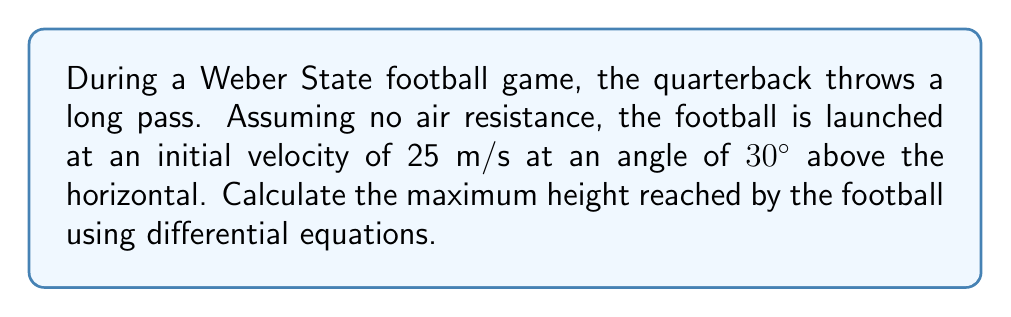Solve this math problem. Let's approach this problem using differential equations:

1. Define variables:
   $x$: horizontal position
   $y$: vertical position
   $t$: time
   $g$: acceleration due to gravity (9.8 m/s²)
   $v_0$: initial velocity (25 m/s)
   $\theta$: launch angle (30°)

2. Set up differential equations:
   $$\frac{d^2x}{dt^2} = 0$$
   $$\frac{d^2y}{dt^2} = -g$$

3. Integrate the equations:
   $$\frac{dx}{dt} = v_0 \cos\theta$$
   $$\frac{dy}{dt} = v_0 \sin\theta - gt$$

4. Integrate again:
   $$x = (v_0 \cos\theta)t$$
   $$y = (v_0 \sin\theta)t - \frac{1}{2}gt^2$$

5. To find the maximum height, we need to find when $\frac{dy}{dt} = 0$:
   $$0 = v_0 \sin\theta - gt_{max}$$
   $$t_{max} = \frac{v_0 \sin\theta}{g}$$

6. Substitute $t_{max}$ into the equation for $y$:
   $$y_{max} = (v_0 \sin\theta)(\frac{v_0 \sin\theta}{g}) - \frac{1}{2}g(\frac{v_0 \sin\theta}{g})^2$$
   $$y_{max} = \frac{v_0^2 \sin^2\theta}{g} - \frac{v_0^2 \sin^2\theta}{2g}$$
   $$y_{max} = \frac{v_0^2 \sin^2\theta}{2g}$$

7. Now, plug in the values:
   $$y_{max} = \frac{(25)^2 \sin^2(30°)}{2(9.8)}$$
   $$y_{max} = \frac{625 \cdot 0.25}{19.6} \approx 7.97 \text{ m}$$
Answer: 7.97 m 